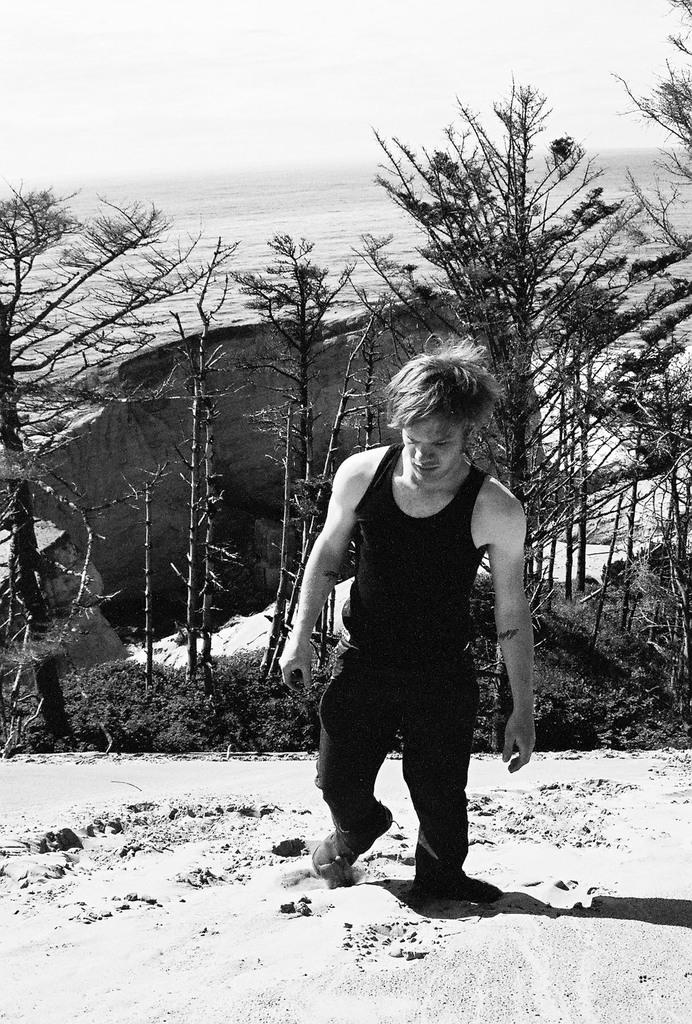What is the person in the image standing on? The person is standing on the snow. What can be seen behind the person in the image? There are trees visible behind the person. What part of the natural environment is visible in the image? The sky is visible in the image. What is the color scheme of the image? The image is black and white. What type of station can be seen in the image? There is no station present in the image. Can you describe the rays emitted by the sun in the image? The image is black and white, so it is not possible to see rays emitted by the sun. 